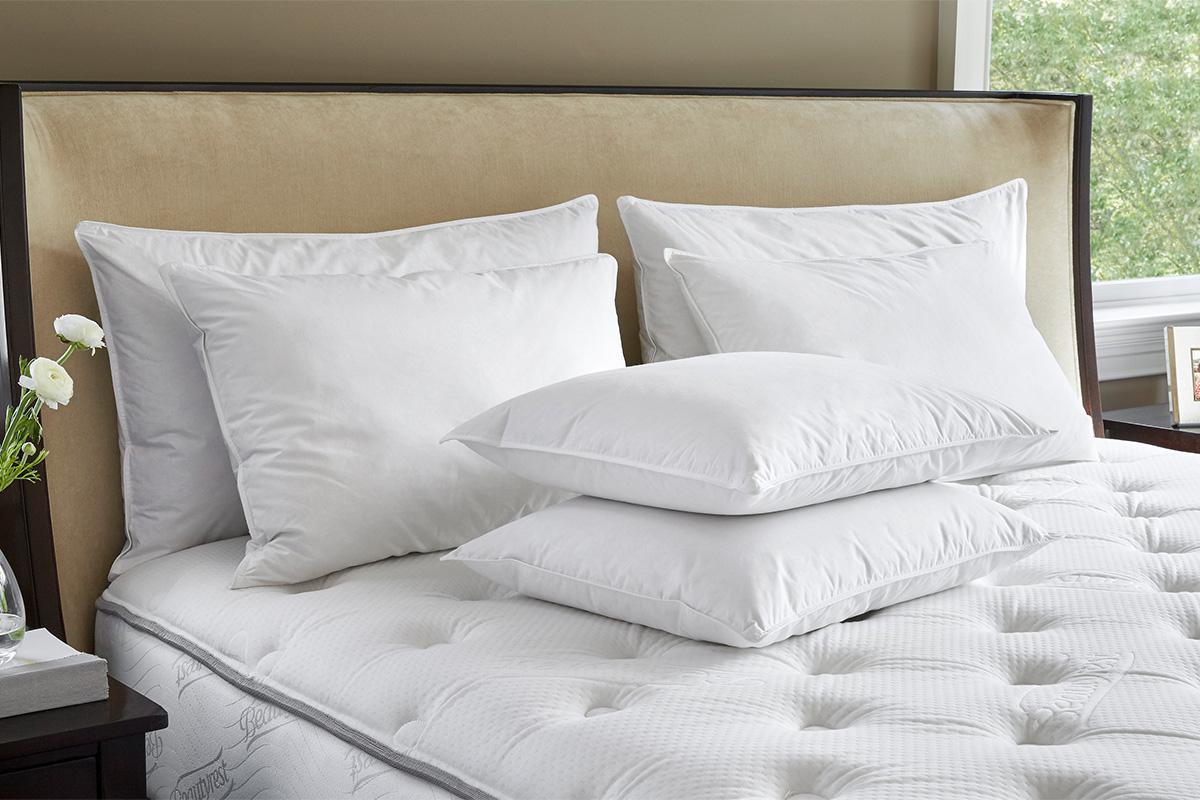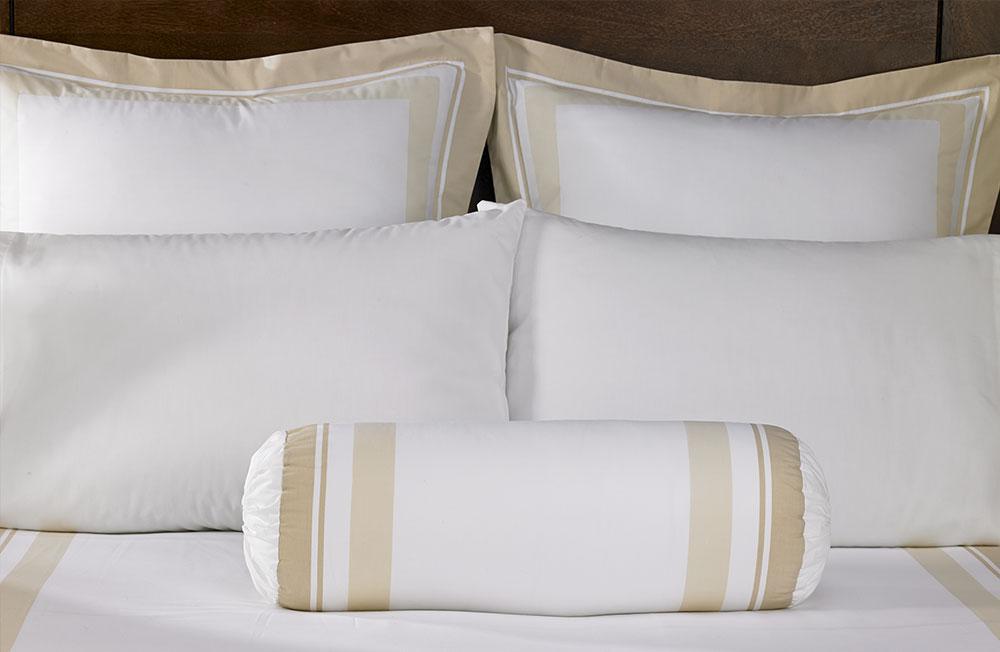The first image is the image on the left, the second image is the image on the right. Assess this claim about the two images: "An image includes a cylindrical pillow with beige bands on each end.". Correct or not? Answer yes or no. Yes. The first image is the image on the left, the second image is the image on the right. Considering the images on both sides, is "In one image a roll pillow with tan stripes is in front of white rectangular upright bed billows." valid? Answer yes or no. Yes. 